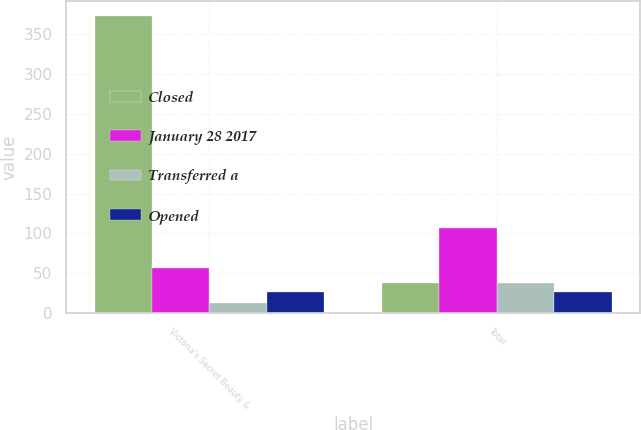<chart> <loc_0><loc_0><loc_500><loc_500><stacked_bar_chart><ecel><fcel>Victoria's Secret Beauty &<fcel>Total<nl><fcel>Closed<fcel>373<fcel>38<nl><fcel>January 28 2017<fcel>56<fcel>107<nl><fcel>Transferred a<fcel>12<fcel>38<nl><fcel>Opened<fcel>26<fcel>26<nl></chart> 